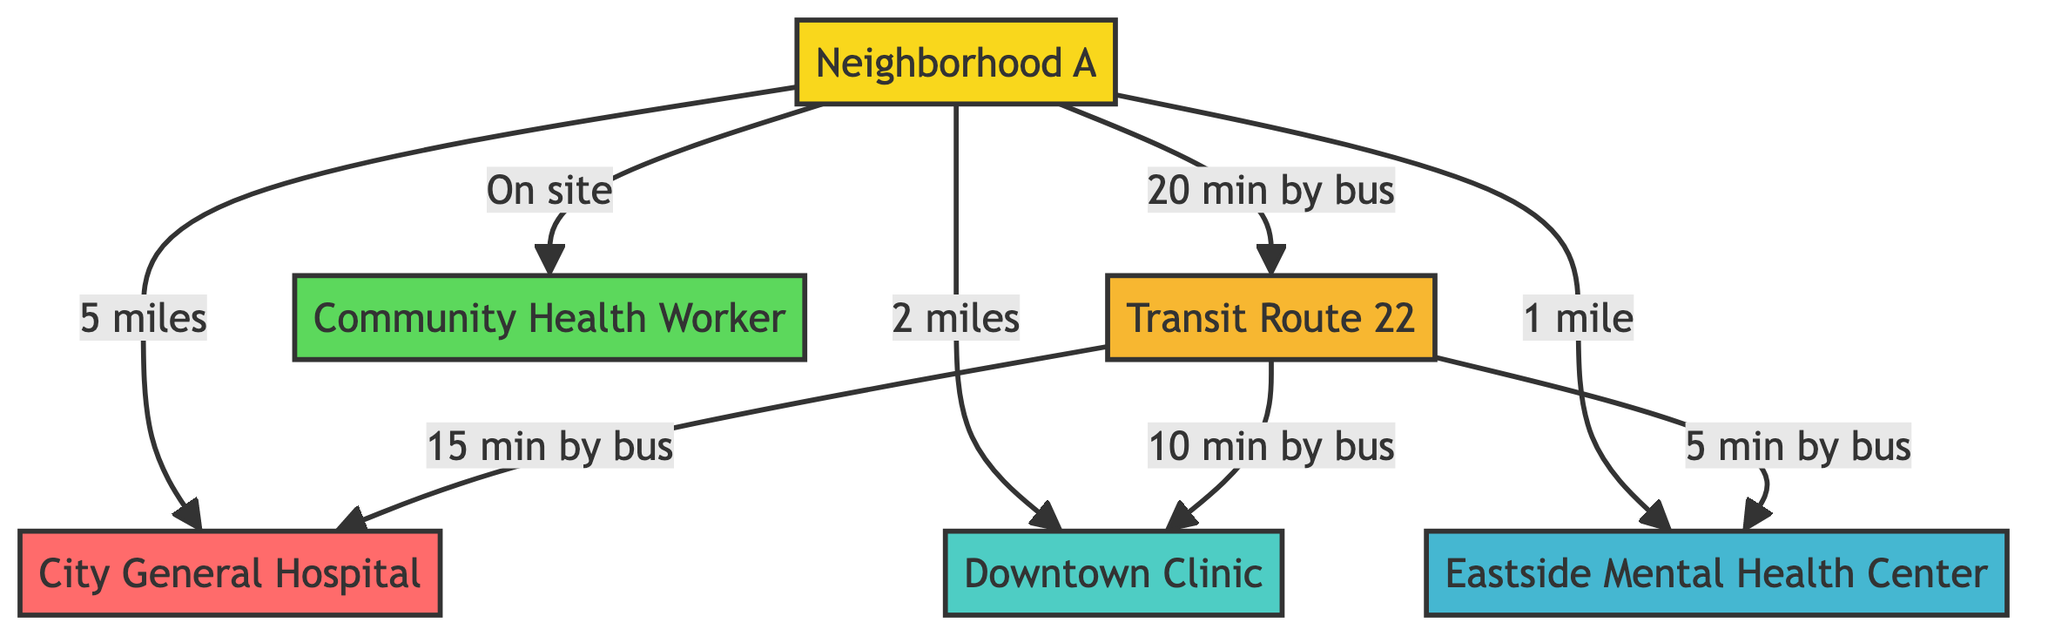What is the distance from Neighborhood A to City General Hospital? The diagram specifies that the distance from Neighborhood A to City General Hospital is labeled as "5 miles."
Answer: 5 miles How far is the Downtown Clinic from Neighborhood A? According to the diagram, the distance from Neighborhood A to the Downtown Clinic is listed as "2 miles."
Answer: 2 miles What type of health services is available on site in Neighborhood A? The diagram indicates that a "Community Health Worker" is available on site in Neighborhood A, representing local health support services.
Answer: Community Health Worker Which mental health service is depicted in the diagram? The Eastside Mental Health Center is the specified mental health service shown in the diagram, addressing mental health needs in the area.
Answer: Eastside Mental Health Center How long does it take to reach the Eastside Mental Health Center by bus? The diagram states it takes "5 min by bus" to get to the Eastside Mental Health Center from Transit Route 22, indicating quick access.
Answer: 5 min by bus What is the connection between the Transit Route 22 and Downtown Clinic? The diagram shows a direct connection stating "10 min by bus" between Transit Route 22 and the Downtown Clinic, highlighting transportation availability.
Answer: 10 min by bus Which service is the closest to Neighborhood A? The diagram shows that the Eastside Mental Health Center is the closest service to Neighborhood A, as it is only "1 mile" away.
Answer: 1 mile What is the total number of health services depicted in the diagram? The diagram includes three types of health services: City General Hospital, Downtown Clinic, and Eastside Mental Health Center, making a total of three health services.
Answer: 3 services What is the relationship between the Transit Route 22 and City General Hospital? The diagram indicates that Transit Route 22 connects to the City General Hospital with a travel time of "15 min by bus," emphasizing transit access to larger healthcare facilities.
Answer: 15 min by bus 